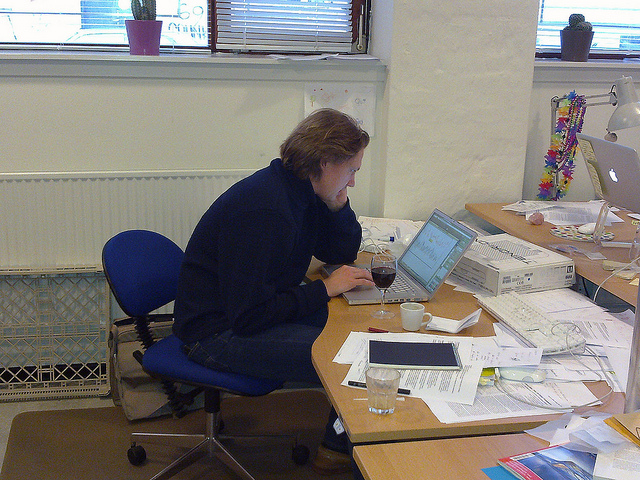Can you describe the working environment shown in the image? The image depicts a cluttered office space with various papers, documents, and office supplies scattered across the desk. A person is concentrated on their work on a laptop, with a blue office chair providing seating. The environment seems hectic and possibly disorganized, which may reflect a busy work period or a less structured approach to workspace management. How might the person improve their work setup to increase productivity? Improving the work setup could involve organizing the desk to reduce clutter, which could help minimize distractions and make essential documents more accessible. Implementing a filing system or using desk organizers could contribute to a clearer workspace. Additionally, the person could position the laptop more centrally and ensure that frequently used items are within easy reach to streamline their workflow. 